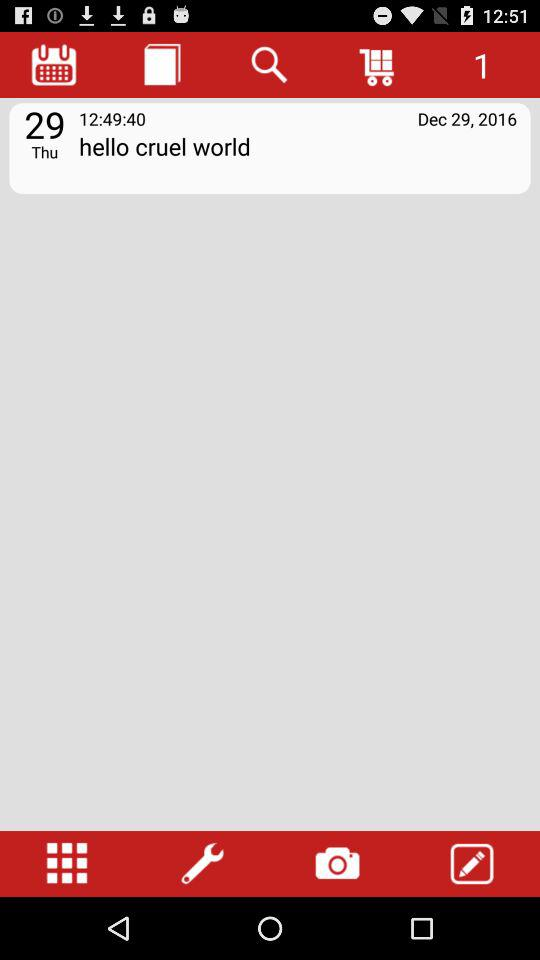What is the day of the selected date? The day of the selected date is Thursday. 